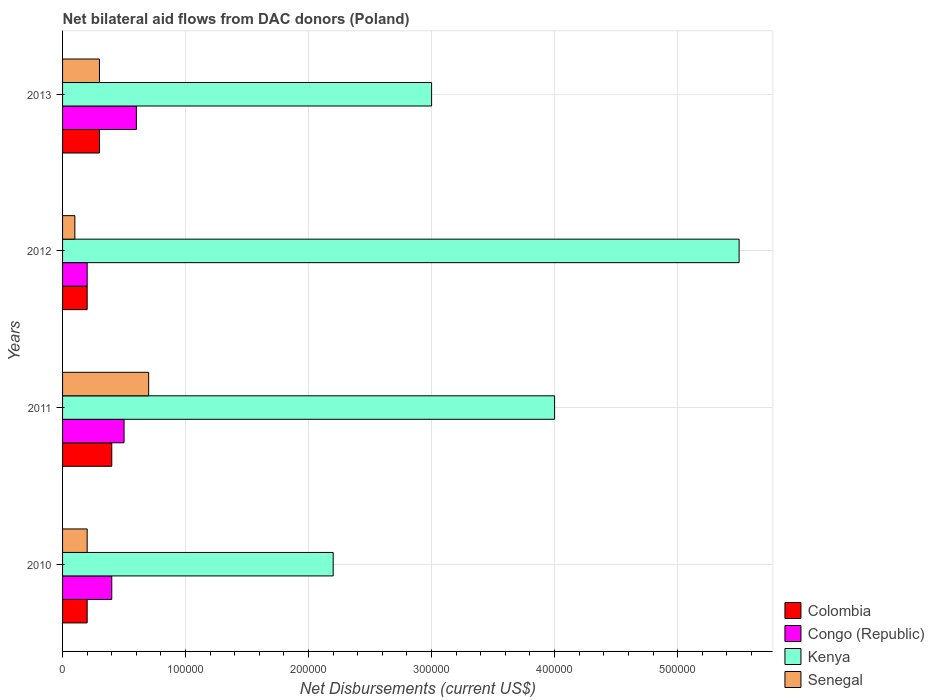How many groups of bars are there?
Make the answer very short. 4. Are the number of bars per tick equal to the number of legend labels?
Keep it short and to the point. Yes. Are the number of bars on each tick of the Y-axis equal?
Make the answer very short. Yes. How many bars are there on the 1st tick from the top?
Provide a succinct answer. 4. What is the net bilateral aid flows in Senegal in 2012?
Provide a succinct answer. 10000. Across all years, what is the maximum net bilateral aid flows in Congo (Republic)?
Provide a short and direct response. 6.00e+04. Across all years, what is the minimum net bilateral aid flows in Colombia?
Make the answer very short. 2.00e+04. In which year was the net bilateral aid flows in Colombia maximum?
Offer a terse response. 2011. In which year was the net bilateral aid flows in Senegal minimum?
Provide a succinct answer. 2012. What is the total net bilateral aid flows in Kenya in the graph?
Offer a terse response. 1.47e+06. What is the average net bilateral aid flows in Kenya per year?
Your answer should be compact. 3.68e+05. In the year 2011, what is the difference between the net bilateral aid flows in Colombia and net bilateral aid flows in Congo (Republic)?
Ensure brevity in your answer.  -10000. In how many years, is the net bilateral aid flows in Kenya greater than 240000 US$?
Offer a terse response. 3. What is the ratio of the net bilateral aid flows in Colombia in 2012 to that in 2013?
Your response must be concise. 0.67. Is the difference between the net bilateral aid flows in Colombia in 2010 and 2011 greater than the difference between the net bilateral aid flows in Congo (Republic) in 2010 and 2011?
Provide a short and direct response. No. What is the difference between the highest and the lowest net bilateral aid flows in Senegal?
Ensure brevity in your answer.  6.00e+04. In how many years, is the net bilateral aid flows in Congo (Republic) greater than the average net bilateral aid flows in Congo (Republic) taken over all years?
Give a very brief answer. 2. Is the sum of the net bilateral aid flows in Congo (Republic) in 2010 and 2012 greater than the maximum net bilateral aid flows in Kenya across all years?
Your answer should be compact. No. Is it the case that in every year, the sum of the net bilateral aid flows in Senegal and net bilateral aid flows in Kenya is greater than the sum of net bilateral aid flows in Congo (Republic) and net bilateral aid flows in Colombia?
Your response must be concise. Yes. What does the 2nd bar from the top in 2012 represents?
Keep it short and to the point. Kenya. What does the 4th bar from the bottom in 2012 represents?
Provide a short and direct response. Senegal. Is it the case that in every year, the sum of the net bilateral aid flows in Colombia and net bilateral aid flows in Kenya is greater than the net bilateral aid flows in Congo (Republic)?
Keep it short and to the point. Yes. How many bars are there?
Your answer should be compact. 16. How many years are there in the graph?
Give a very brief answer. 4. What is the difference between two consecutive major ticks on the X-axis?
Offer a very short reply. 1.00e+05. Are the values on the major ticks of X-axis written in scientific E-notation?
Provide a short and direct response. No. Does the graph contain grids?
Provide a succinct answer. Yes. Where does the legend appear in the graph?
Offer a very short reply. Bottom right. How many legend labels are there?
Ensure brevity in your answer.  4. What is the title of the graph?
Ensure brevity in your answer.  Net bilateral aid flows from DAC donors (Poland). What is the label or title of the X-axis?
Provide a short and direct response. Net Disbursements (current US$). What is the label or title of the Y-axis?
Your response must be concise. Years. What is the Net Disbursements (current US$) of Colombia in 2011?
Provide a short and direct response. 4.00e+04. What is the Net Disbursements (current US$) in Congo (Republic) in 2012?
Make the answer very short. 2.00e+04. What is the Net Disbursements (current US$) in Kenya in 2012?
Your answer should be very brief. 5.50e+05. What is the Net Disbursements (current US$) of Senegal in 2012?
Keep it short and to the point. 10000. What is the Net Disbursements (current US$) in Congo (Republic) in 2013?
Offer a very short reply. 6.00e+04. What is the Net Disbursements (current US$) in Kenya in 2013?
Offer a terse response. 3.00e+05. Across all years, what is the maximum Net Disbursements (current US$) of Colombia?
Your answer should be very brief. 4.00e+04. Across all years, what is the maximum Net Disbursements (current US$) in Congo (Republic)?
Make the answer very short. 6.00e+04. Across all years, what is the minimum Net Disbursements (current US$) in Colombia?
Offer a terse response. 2.00e+04. Across all years, what is the minimum Net Disbursements (current US$) of Senegal?
Provide a succinct answer. 10000. What is the total Net Disbursements (current US$) of Congo (Republic) in the graph?
Your answer should be very brief. 1.70e+05. What is the total Net Disbursements (current US$) in Kenya in the graph?
Offer a very short reply. 1.47e+06. What is the total Net Disbursements (current US$) in Senegal in the graph?
Give a very brief answer. 1.30e+05. What is the difference between the Net Disbursements (current US$) in Colombia in 2010 and that in 2011?
Your answer should be very brief. -2.00e+04. What is the difference between the Net Disbursements (current US$) in Congo (Republic) in 2010 and that in 2011?
Your answer should be very brief. -10000. What is the difference between the Net Disbursements (current US$) of Kenya in 2010 and that in 2011?
Provide a short and direct response. -1.80e+05. What is the difference between the Net Disbursements (current US$) in Senegal in 2010 and that in 2011?
Keep it short and to the point. -5.00e+04. What is the difference between the Net Disbursements (current US$) in Congo (Republic) in 2010 and that in 2012?
Make the answer very short. 2.00e+04. What is the difference between the Net Disbursements (current US$) in Kenya in 2010 and that in 2012?
Your answer should be very brief. -3.30e+05. What is the difference between the Net Disbursements (current US$) in Senegal in 2010 and that in 2012?
Keep it short and to the point. 10000. What is the difference between the Net Disbursements (current US$) of Congo (Republic) in 2010 and that in 2013?
Your answer should be very brief. -2.00e+04. What is the difference between the Net Disbursements (current US$) of Colombia in 2011 and that in 2012?
Your answer should be very brief. 2.00e+04. What is the difference between the Net Disbursements (current US$) in Congo (Republic) in 2011 and that in 2012?
Make the answer very short. 3.00e+04. What is the difference between the Net Disbursements (current US$) in Senegal in 2011 and that in 2013?
Offer a terse response. 4.00e+04. What is the difference between the Net Disbursements (current US$) of Congo (Republic) in 2012 and that in 2013?
Provide a succinct answer. -4.00e+04. What is the difference between the Net Disbursements (current US$) in Kenya in 2012 and that in 2013?
Your response must be concise. 2.50e+05. What is the difference between the Net Disbursements (current US$) of Colombia in 2010 and the Net Disbursements (current US$) of Congo (Republic) in 2011?
Keep it short and to the point. -3.00e+04. What is the difference between the Net Disbursements (current US$) in Colombia in 2010 and the Net Disbursements (current US$) in Kenya in 2011?
Your answer should be compact. -3.80e+05. What is the difference between the Net Disbursements (current US$) of Congo (Republic) in 2010 and the Net Disbursements (current US$) of Kenya in 2011?
Keep it short and to the point. -3.60e+05. What is the difference between the Net Disbursements (current US$) of Congo (Republic) in 2010 and the Net Disbursements (current US$) of Senegal in 2011?
Keep it short and to the point. -3.00e+04. What is the difference between the Net Disbursements (current US$) in Colombia in 2010 and the Net Disbursements (current US$) in Kenya in 2012?
Make the answer very short. -5.30e+05. What is the difference between the Net Disbursements (current US$) of Colombia in 2010 and the Net Disbursements (current US$) of Senegal in 2012?
Offer a very short reply. 10000. What is the difference between the Net Disbursements (current US$) of Congo (Republic) in 2010 and the Net Disbursements (current US$) of Kenya in 2012?
Offer a very short reply. -5.10e+05. What is the difference between the Net Disbursements (current US$) in Congo (Republic) in 2010 and the Net Disbursements (current US$) in Senegal in 2012?
Your answer should be compact. 3.00e+04. What is the difference between the Net Disbursements (current US$) in Colombia in 2010 and the Net Disbursements (current US$) in Congo (Republic) in 2013?
Your answer should be compact. -4.00e+04. What is the difference between the Net Disbursements (current US$) in Colombia in 2010 and the Net Disbursements (current US$) in Kenya in 2013?
Provide a short and direct response. -2.80e+05. What is the difference between the Net Disbursements (current US$) of Colombia in 2010 and the Net Disbursements (current US$) of Senegal in 2013?
Give a very brief answer. -10000. What is the difference between the Net Disbursements (current US$) in Congo (Republic) in 2010 and the Net Disbursements (current US$) in Senegal in 2013?
Offer a very short reply. 10000. What is the difference between the Net Disbursements (current US$) of Kenya in 2010 and the Net Disbursements (current US$) of Senegal in 2013?
Keep it short and to the point. 1.90e+05. What is the difference between the Net Disbursements (current US$) in Colombia in 2011 and the Net Disbursements (current US$) in Kenya in 2012?
Give a very brief answer. -5.10e+05. What is the difference between the Net Disbursements (current US$) of Colombia in 2011 and the Net Disbursements (current US$) of Senegal in 2012?
Give a very brief answer. 3.00e+04. What is the difference between the Net Disbursements (current US$) in Congo (Republic) in 2011 and the Net Disbursements (current US$) in Kenya in 2012?
Keep it short and to the point. -5.00e+05. What is the difference between the Net Disbursements (current US$) in Congo (Republic) in 2011 and the Net Disbursements (current US$) in Senegal in 2012?
Your answer should be very brief. 4.00e+04. What is the difference between the Net Disbursements (current US$) in Kenya in 2011 and the Net Disbursements (current US$) in Senegal in 2012?
Ensure brevity in your answer.  3.90e+05. What is the difference between the Net Disbursements (current US$) in Colombia in 2011 and the Net Disbursements (current US$) in Congo (Republic) in 2013?
Your response must be concise. -2.00e+04. What is the difference between the Net Disbursements (current US$) in Congo (Republic) in 2011 and the Net Disbursements (current US$) in Kenya in 2013?
Offer a very short reply. -2.50e+05. What is the difference between the Net Disbursements (current US$) of Kenya in 2011 and the Net Disbursements (current US$) of Senegal in 2013?
Make the answer very short. 3.70e+05. What is the difference between the Net Disbursements (current US$) of Colombia in 2012 and the Net Disbursements (current US$) of Congo (Republic) in 2013?
Your response must be concise. -4.00e+04. What is the difference between the Net Disbursements (current US$) in Colombia in 2012 and the Net Disbursements (current US$) in Kenya in 2013?
Keep it short and to the point. -2.80e+05. What is the difference between the Net Disbursements (current US$) in Congo (Republic) in 2012 and the Net Disbursements (current US$) in Kenya in 2013?
Your response must be concise. -2.80e+05. What is the difference between the Net Disbursements (current US$) of Congo (Republic) in 2012 and the Net Disbursements (current US$) of Senegal in 2013?
Your response must be concise. -10000. What is the difference between the Net Disbursements (current US$) of Kenya in 2012 and the Net Disbursements (current US$) of Senegal in 2013?
Provide a short and direct response. 5.20e+05. What is the average Net Disbursements (current US$) of Colombia per year?
Provide a short and direct response. 2.75e+04. What is the average Net Disbursements (current US$) of Congo (Republic) per year?
Offer a terse response. 4.25e+04. What is the average Net Disbursements (current US$) in Kenya per year?
Your answer should be very brief. 3.68e+05. What is the average Net Disbursements (current US$) in Senegal per year?
Offer a terse response. 3.25e+04. In the year 2010, what is the difference between the Net Disbursements (current US$) of Colombia and Net Disbursements (current US$) of Congo (Republic)?
Provide a succinct answer. -2.00e+04. In the year 2010, what is the difference between the Net Disbursements (current US$) of Kenya and Net Disbursements (current US$) of Senegal?
Your response must be concise. 2.00e+05. In the year 2011, what is the difference between the Net Disbursements (current US$) in Colombia and Net Disbursements (current US$) in Kenya?
Offer a terse response. -3.60e+05. In the year 2011, what is the difference between the Net Disbursements (current US$) in Colombia and Net Disbursements (current US$) in Senegal?
Keep it short and to the point. -3.00e+04. In the year 2011, what is the difference between the Net Disbursements (current US$) of Congo (Republic) and Net Disbursements (current US$) of Kenya?
Give a very brief answer. -3.50e+05. In the year 2011, what is the difference between the Net Disbursements (current US$) of Congo (Republic) and Net Disbursements (current US$) of Senegal?
Provide a short and direct response. -2.00e+04. In the year 2012, what is the difference between the Net Disbursements (current US$) in Colombia and Net Disbursements (current US$) in Kenya?
Give a very brief answer. -5.30e+05. In the year 2012, what is the difference between the Net Disbursements (current US$) of Colombia and Net Disbursements (current US$) of Senegal?
Offer a very short reply. 10000. In the year 2012, what is the difference between the Net Disbursements (current US$) of Congo (Republic) and Net Disbursements (current US$) of Kenya?
Your answer should be compact. -5.30e+05. In the year 2012, what is the difference between the Net Disbursements (current US$) in Congo (Republic) and Net Disbursements (current US$) in Senegal?
Make the answer very short. 10000. In the year 2012, what is the difference between the Net Disbursements (current US$) in Kenya and Net Disbursements (current US$) in Senegal?
Provide a short and direct response. 5.40e+05. In the year 2013, what is the difference between the Net Disbursements (current US$) in Colombia and Net Disbursements (current US$) in Congo (Republic)?
Offer a very short reply. -3.00e+04. In the year 2013, what is the difference between the Net Disbursements (current US$) of Colombia and Net Disbursements (current US$) of Kenya?
Your response must be concise. -2.70e+05. In the year 2013, what is the difference between the Net Disbursements (current US$) in Colombia and Net Disbursements (current US$) in Senegal?
Your answer should be compact. 0. In the year 2013, what is the difference between the Net Disbursements (current US$) in Congo (Republic) and Net Disbursements (current US$) in Kenya?
Ensure brevity in your answer.  -2.40e+05. In the year 2013, what is the difference between the Net Disbursements (current US$) of Congo (Republic) and Net Disbursements (current US$) of Senegal?
Keep it short and to the point. 3.00e+04. What is the ratio of the Net Disbursements (current US$) of Colombia in 2010 to that in 2011?
Offer a very short reply. 0.5. What is the ratio of the Net Disbursements (current US$) in Congo (Republic) in 2010 to that in 2011?
Your response must be concise. 0.8. What is the ratio of the Net Disbursements (current US$) of Kenya in 2010 to that in 2011?
Offer a very short reply. 0.55. What is the ratio of the Net Disbursements (current US$) of Senegal in 2010 to that in 2011?
Offer a very short reply. 0.29. What is the ratio of the Net Disbursements (current US$) in Colombia in 2010 to that in 2012?
Your answer should be compact. 1. What is the ratio of the Net Disbursements (current US$) of Kenya in 2010 to that in 2012?
Your answer should be very brief. 0.4. What is the ratio of the Net Disbursements (current US$) in Kenya in 2010 to that in 2013?
Provide a succinct answer. 0.73. What is the ratio of the Net Disbursements (current US$) of Kenya in 2011 to that in 2012?
Give a very brief answer. 0.73. What is the ratio of the Net Disbursements (current US$) in Colombia in 2011 to that in 2013?
Make the answer very short. 1.33. What is the ratio of the Net Disbursements (current US$) of Kenya in 2011 to that in 2013?
Give a very brief answer. 1.33. What is the ratio of the Net Disbursements (current US$) in Senegal in 2011 to that in 2013?
Make the answer very short. 2.33. What is the ratio of the Net Disbursements (current US$) of Kenya in 2012 to that in 2013?
Provide a succinct answer. 1.83. What is the difference between the highest and the lowest Net Disbursements (current US$) of Colombia?
Provide a succinct answer. 2.00e+04. 